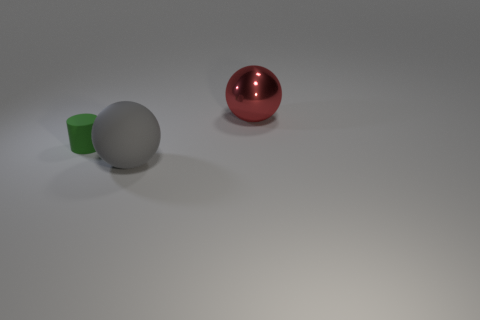Subtract all blue balls. Subtract all cyan cylinders. How many balls are left? 2 Add 1 green metallic balls. How many objects exist? 4 Subtract all cylinders. How many objects are left? 2 Add 1 large red things. How many large red things exist? 2 Subtract 0 yellow spheres. How many objects are left? 3 Subtract all green matte cylinders. Subtract all green objects. How many objects are left? 1 Add 1 small green cylinders. How many small green cylinders are left? 2 